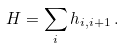<formula> <loc_0><loc_0><loc_500><loc_500>H = \sum _ { i } h _ { i , i + 1 } \, .</formula> 